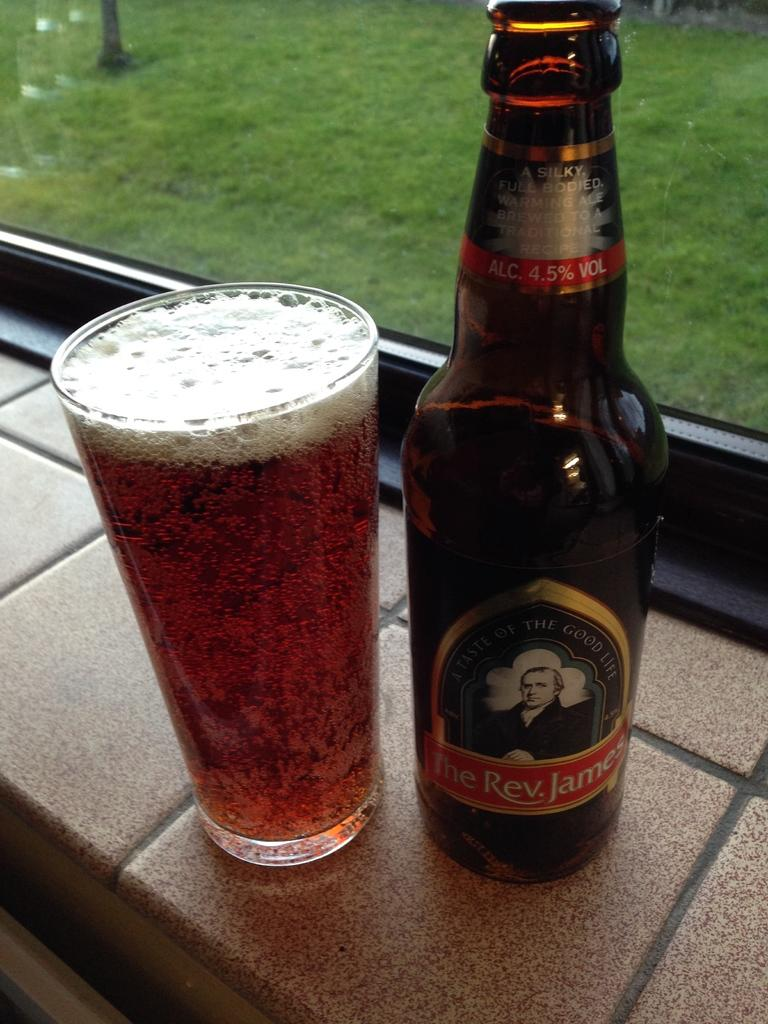<image>
Offer a succinct explanation of the picture presented. a bottle of the rev. james next to a glass full of it 